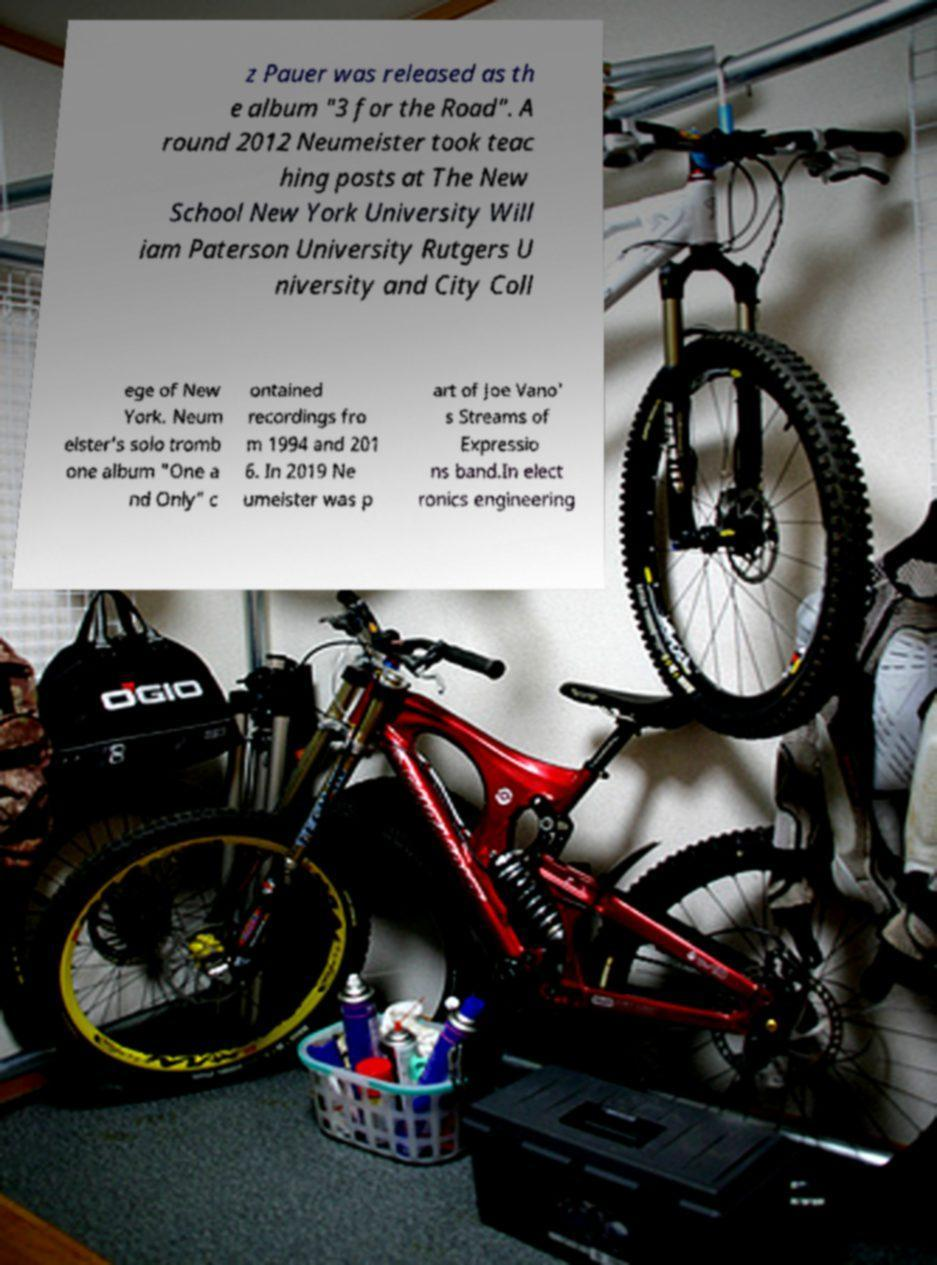There's text embedded in this image that I need extracted. Can you transcribe it verbatim? z Pauer was released as th e album "3 for the Road". A round 2012 Neumeister took teac hing posts at The New School New York University Will iam Paterson University Rutgers U niversity and City Coll ege of New York. Neum eister's solo tromb one album "One a nd Only" c ontained recordings fro m 1994 and 201 6. In 2019 Ne umeister was p art of Joe Vano' s Streams of Expressio ns band.In elect ronics engineering 